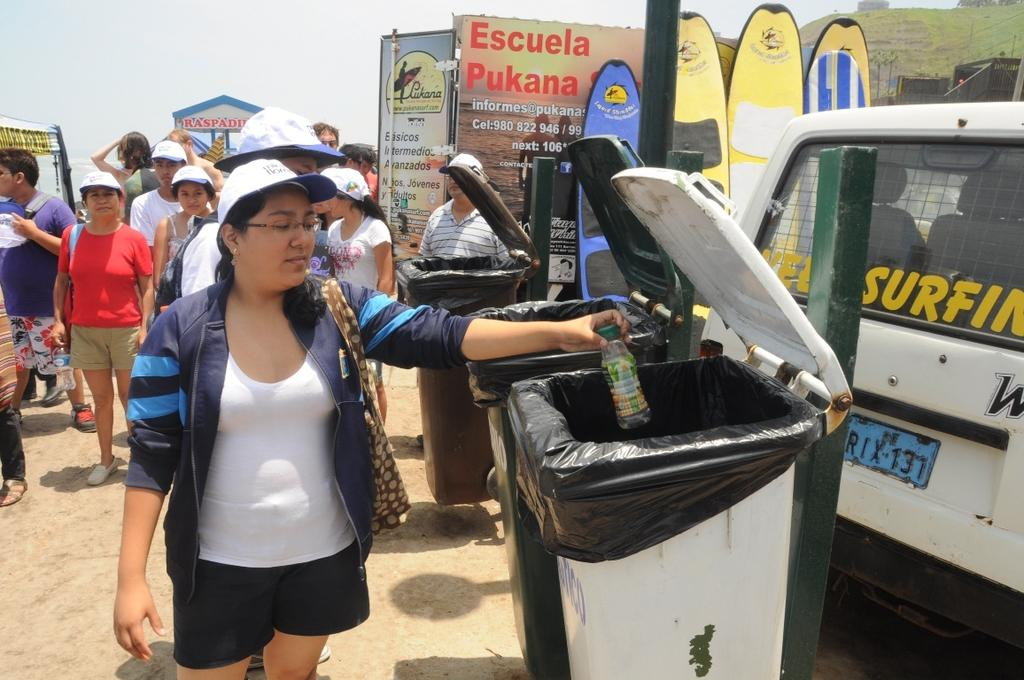<image>
Summarize the visual content of the image. A woman discards trash in front of a sign that says Escuela Pukana. 